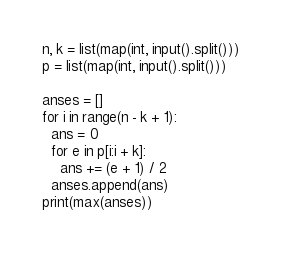<code> <loc_0><loc_0><loc_500><loc_500><_Python_>n, k = list(map(int, input().split()))
p = list(map(int, input().split()))

anses = []
for i in range(n - k + 1):
  ans = 0
  for e in p[i:i + k]:
    ans += (e + 1) / 2
  anses.append(ans)
print(max(anses))
</code> 